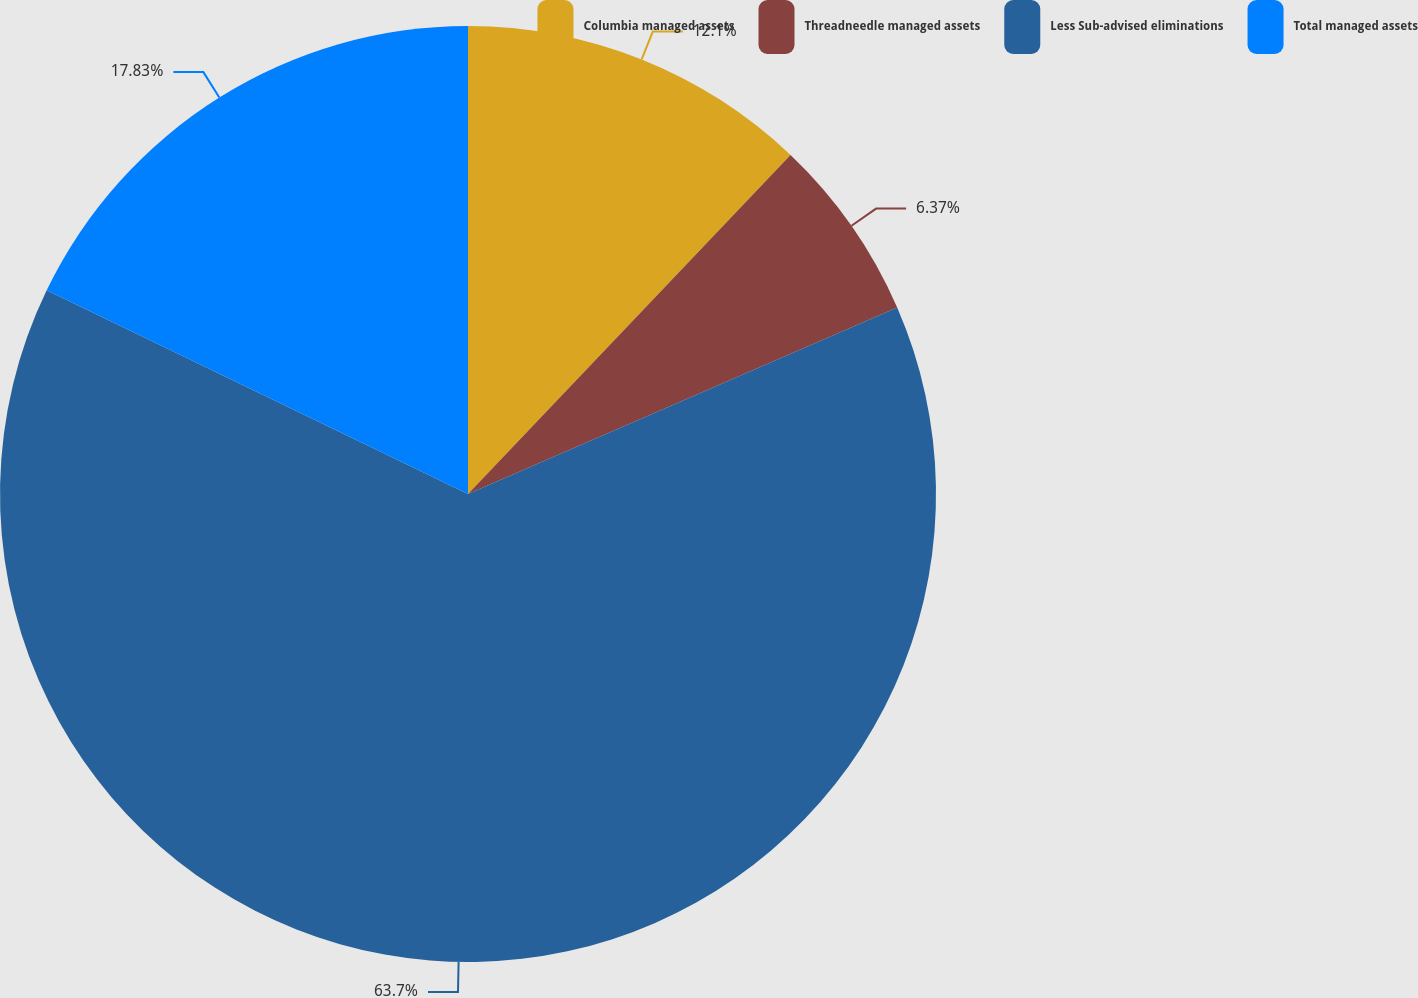<chart> <loc_0><loc_0><loc_500><loc_500><pie_chart><fcel>Columbia managed assets<fcel>Threadneedle managed assets<fcel>Less Sub-advised eliminations<fcel>Total managed assets<nl><fcel>12.1%<fcel>6.37%<fcel>63.69%<fcel>17.83%<nl></chart> 